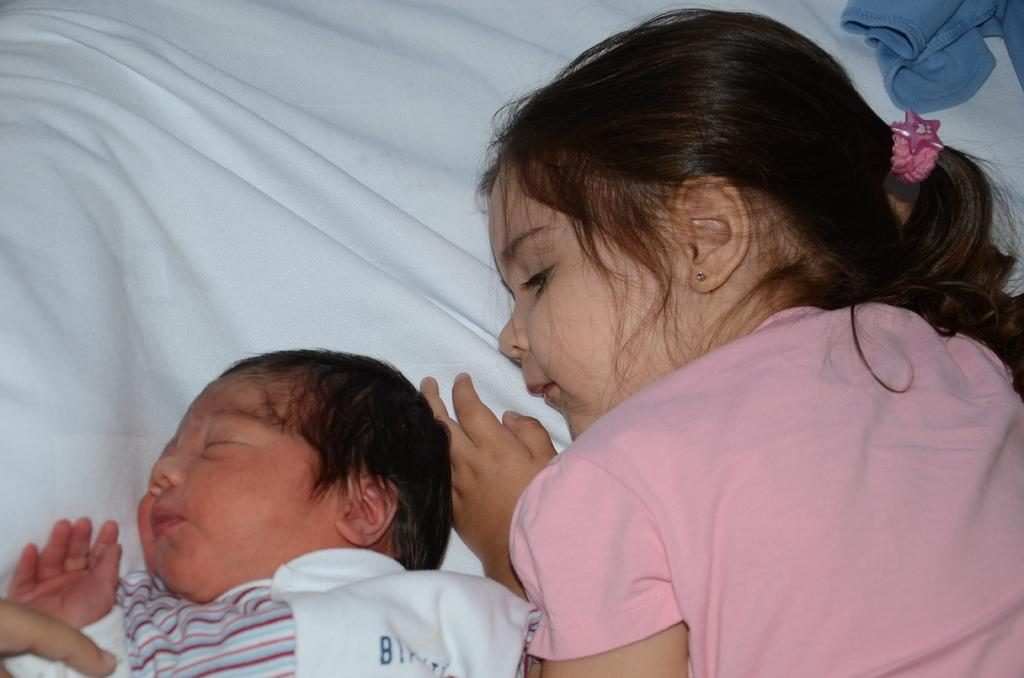What is the main object in the image? There is a bed in the image. What are the kids doing on the bed? Two kids are lying on the bed. Can you describe any other visible objects in the image? There is a cloth visible in the top right corner of the image. What type of stage is visible in the image? There is no stage present in the image; it features a bed with two kids lying on it and a cloth in the top right corner. What kind of quill is being used by the kids on the bed? There is no quill present in the image; the kids are simply lying on the bed. 